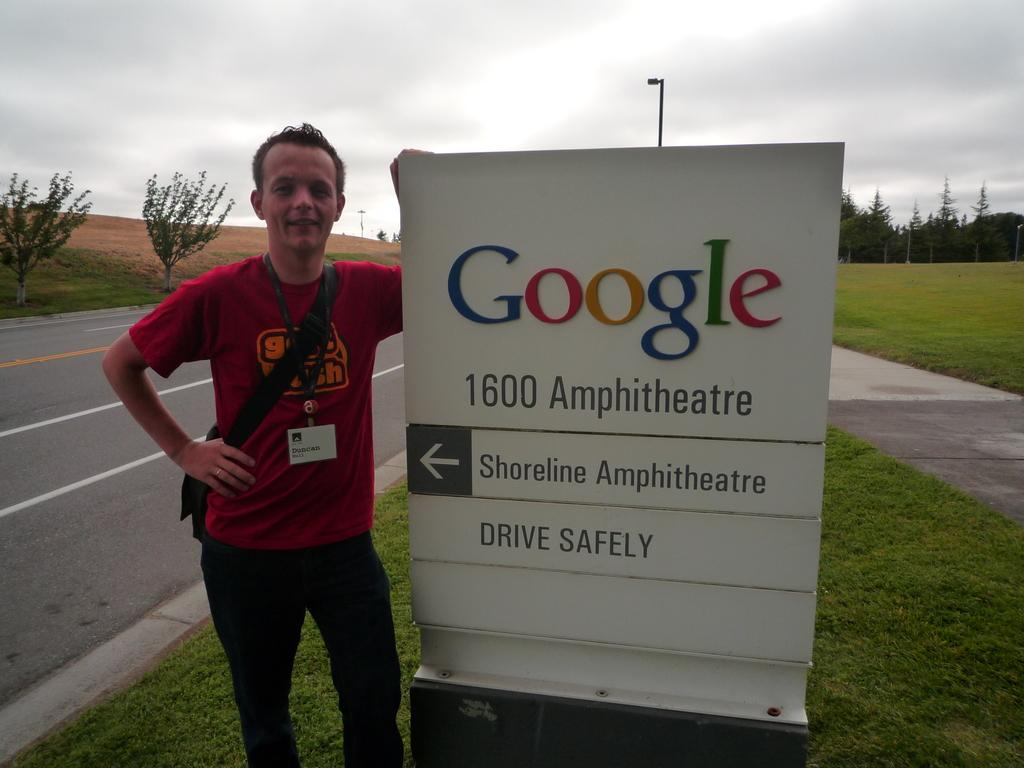<image>
Describe the image concisely. a man is posing with a google sign 